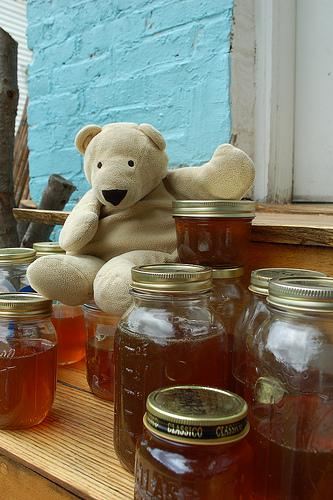Question: what stuffed animal is in the photo?
Choices:
A. Rabbit.
B. Puppy.
C. Kitten.
D. Bear.
Answer with the letter. Answer: D Question: what is in the jars?
Choices:
A. Honey.
B. Spices.
C. Sauce.
D. Soup.
Answer with the letter. Answer: A Question: what color is the bear?
Choices:
A. Black.
B. White.
C. Yellow.
D. Brown.
Answer with the letter. Answer: D Question: how many jars are there?
Choices:
A. 9.
B. 8.
C. 10.
D. 7.
Answer with the letter. Answer: C Question: where are the jars?
Choices:
A. Refrigerator.
B. Pantry.
C. Counter.
D. Cupboard.
Answer with the letter. Answer: C Question: what color is the wall?
Choices:
A. Purple.
B. Black.
C. Gray.
D. Blue.
Answer with the letter. Answer: D Question: where was the photo taken?
Choices:
A. Dining room.
B. Front room.
C. Kitchen.
D. Basement.
Answer with the letter. Answer: C 